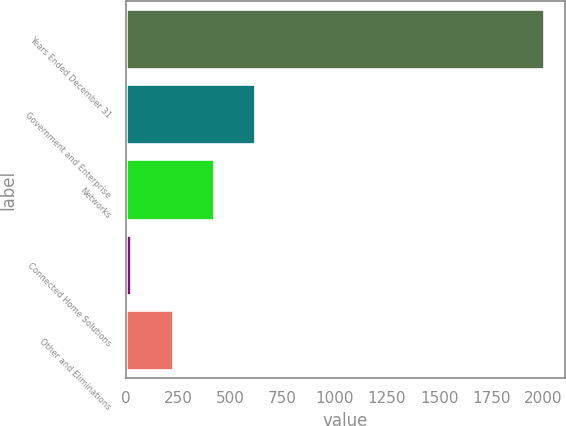Convert chart. <chart><loc_0><loc_0><loc_500><loc_500><bar_chart><fcel>Years Ended December 31<fcel>Government and Enterprise<fcel>Networks<fcel>Connected Home Solutions<fcel>Other and Eliminations<nl><fcel>2004<fcel>620.1<fcel>422.4<fcel>27<fcel>224.7<nl></chart> 